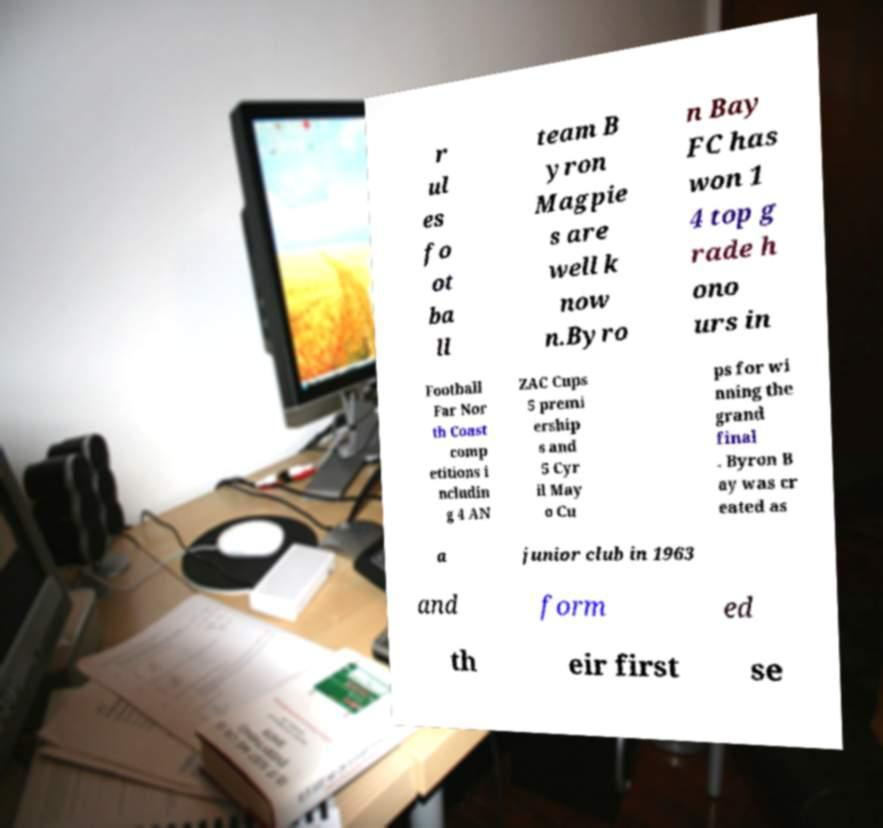Can you accurately transcribe the text from the provided image for me? r ul es fo ot ba ll team B yron Magpie s are well k now n.Byro n Bay FC has won 1 4 top g rade h ono urs in Football Far Nor th Coast comp etitions i ncludin g 4 AN ZAC Cups 5 premi ership s and 5 Cyr il May o Cu ps for wi nning the grand final . Byron B ay was cr eated as a junior club in 1963 and form ed th eir first se 